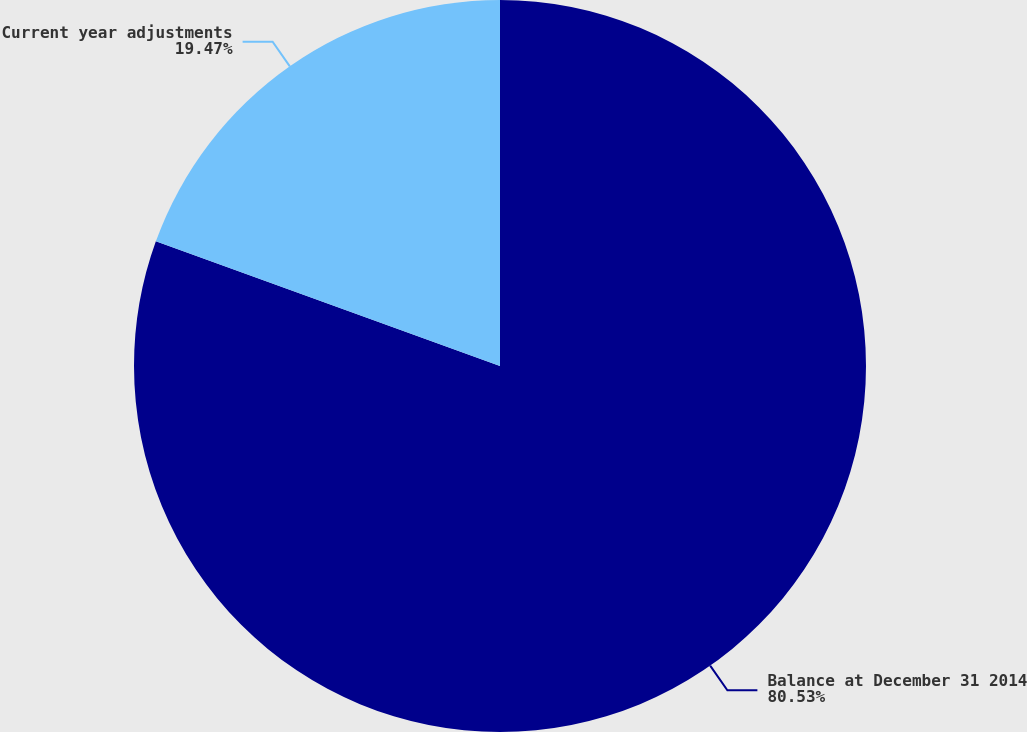Convert chart to OTSL. <chart><loc_0><loc_0><loc_500><loc_500><pie_chart><fcel>Balance at December 31 2014<fcel>Current year adjustments<nl><fcel>80.53%<fcel>19.47%<nl></chart> 